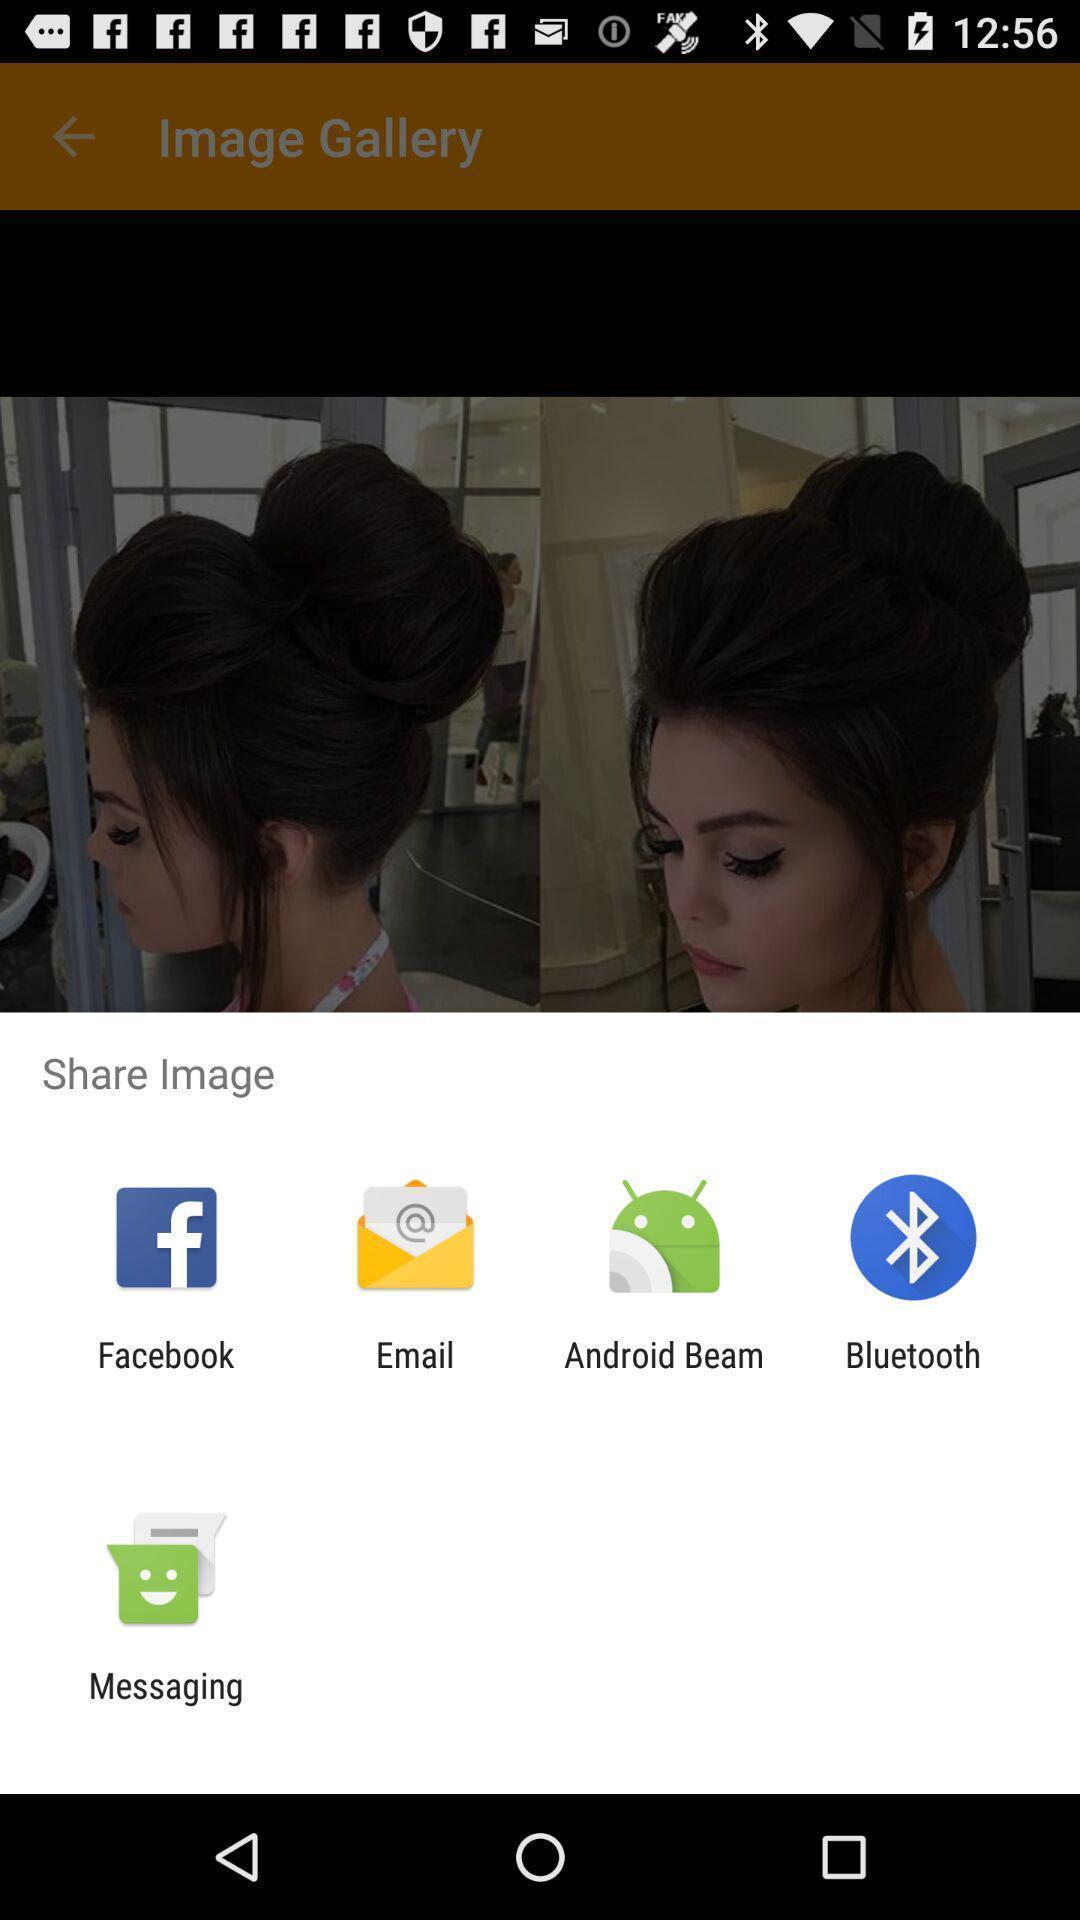Please provide a description for this image. Popup page for sharing an image through different apps. 